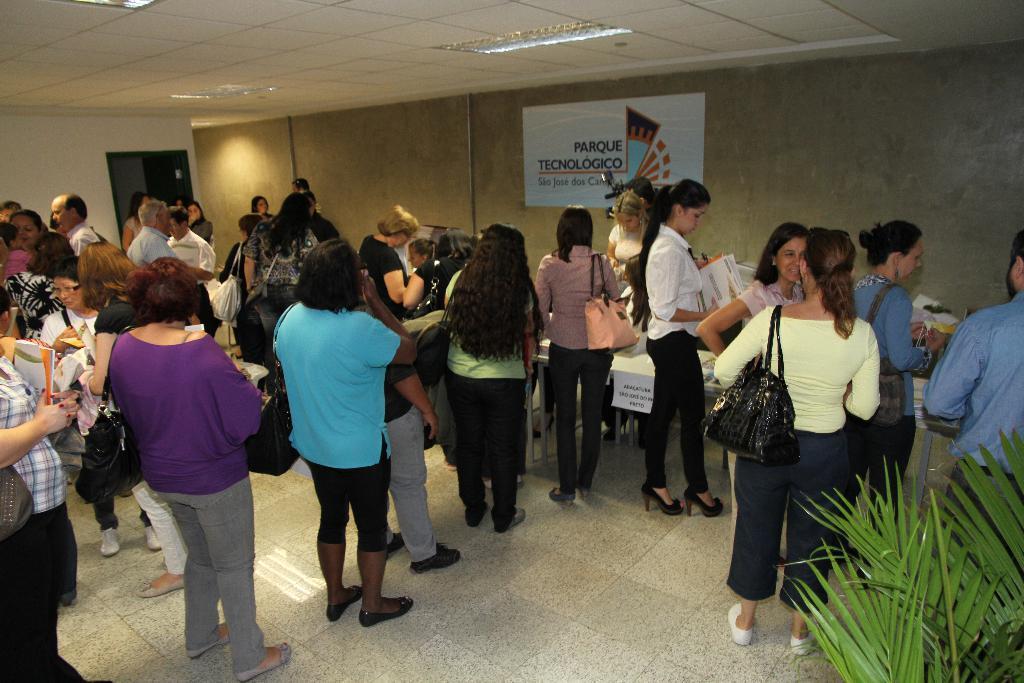In one or two sentences, can you explain what this image depicts? In this image there are group of person standing, there is a poster on the wall, there are lights on the roof, there is a door, there is a wall, there is a tree truncated to the right of the image, there is a person truncated towards the right of the image. 